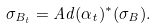<formula> <loc_0><loc_0><loc_500><loc_500>\sigma _ { B _ { t } } = A d ( \alpha _ { t } ) ^ { * } ( \sigma _ { B } ) .</formula> 